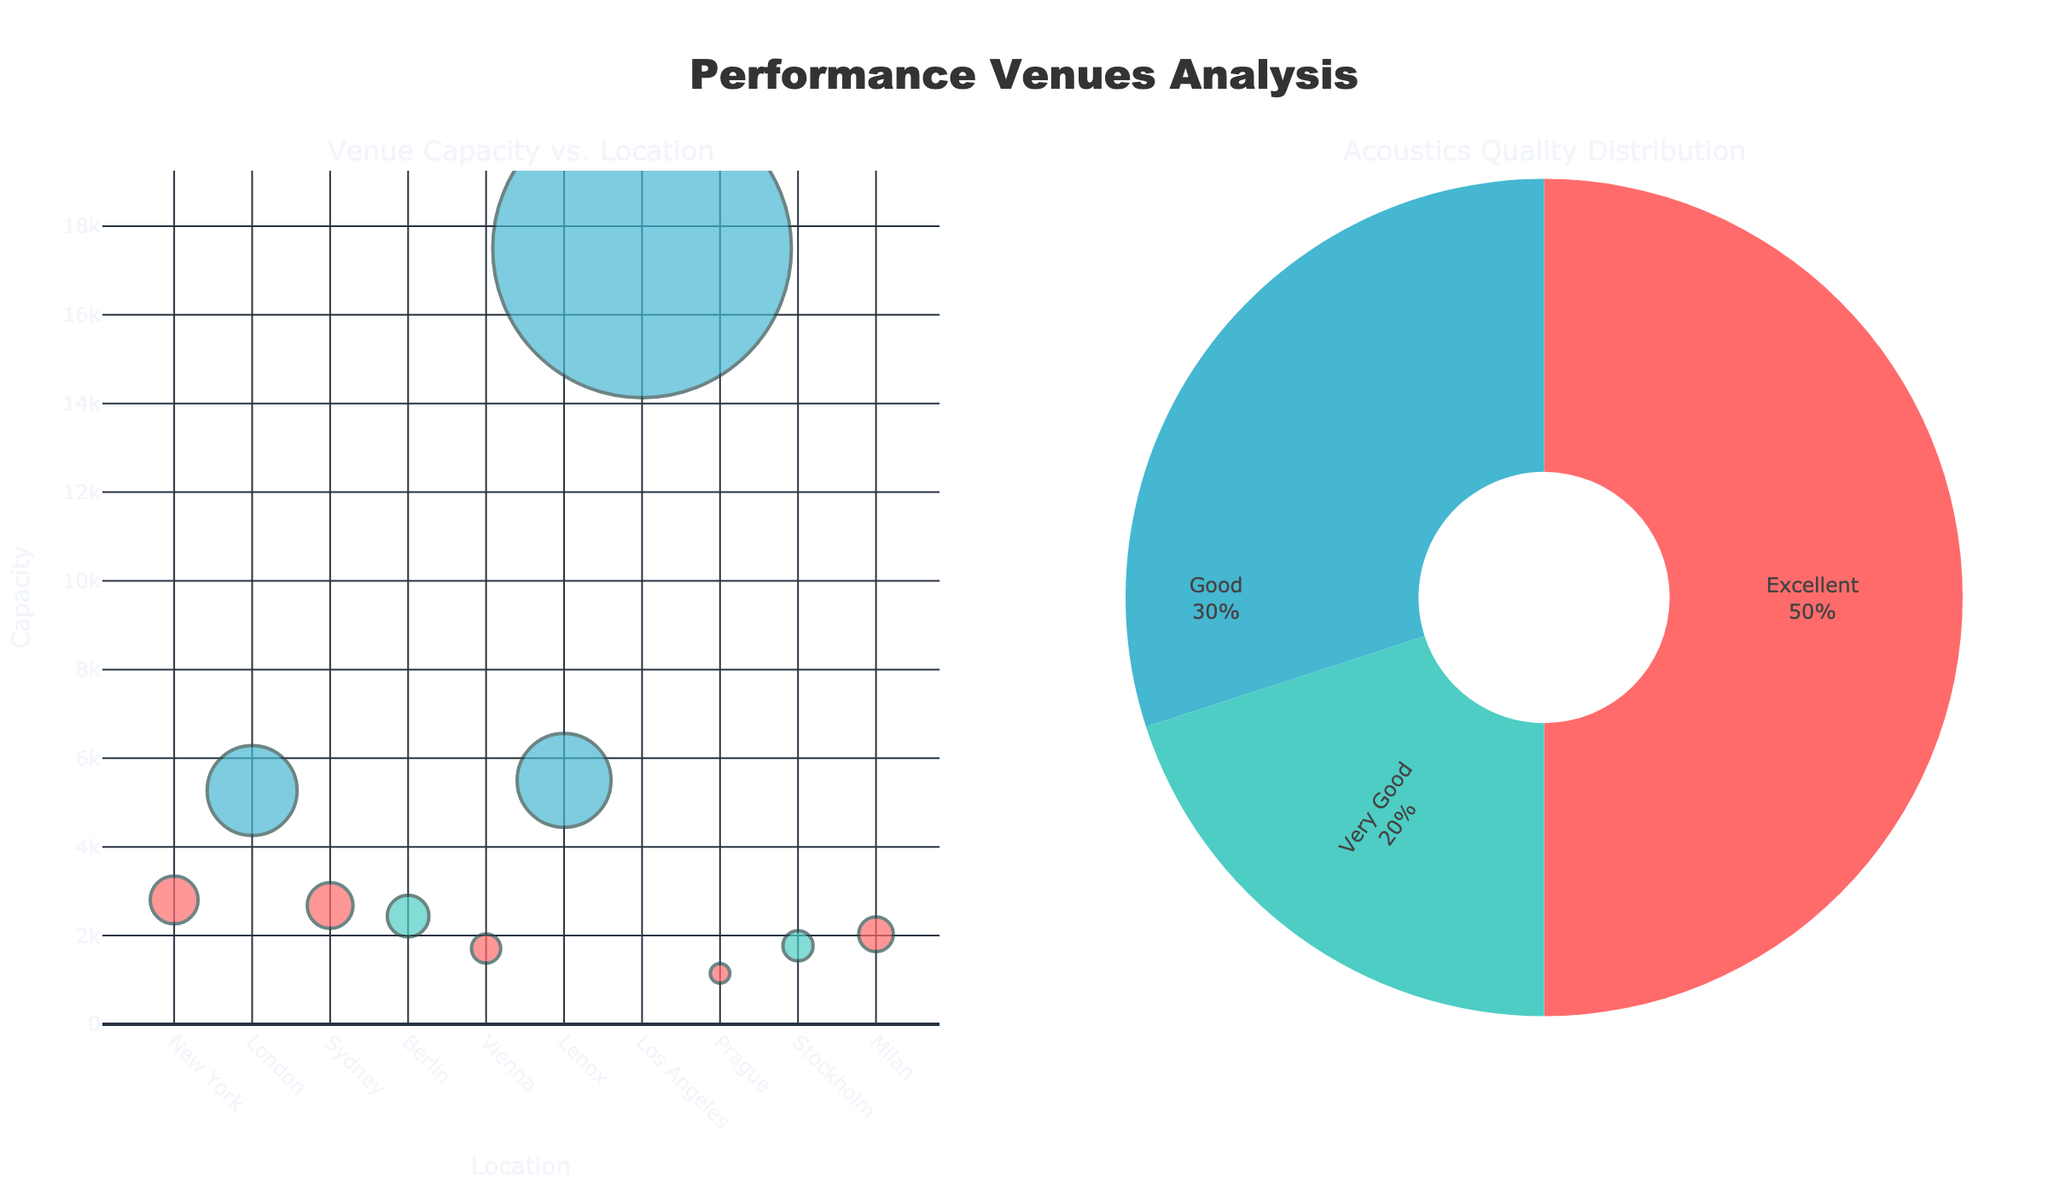What is the title of the figure? The title of the figure is positioned at the top center and provides an overview of the data representation. The title is "Performance Venues Analysis".
Answer: Performance Venues Analysis Which venue has the largest capacity? To find the venue with the largest capacity, look at the y-axis values in the scatter plot and identify the highest value. The Hollywood Bowl in Los Angeles has the largest capacity at 17,500.
Answer: Hollywood Bowl How many venues have an "Excellent" acoustics quality? This information can be found in the pie chart, which displays the distribution of acoustics quality. According to the pie chart, there are 5 venues with "Excellent" acoustics quality.
Answer: 5 What is the smallest venue by capacity, and what is its acoustics quality? Identify the smallest y-axis value in the scatter plot and cross-reference its color to determine the acoustics quality. The Rudolfinum in Prague has the smallest capacity of 1,148 and it has "Excellent" acoustics quality.
Answer: Rudolfinum, Excellent What are the capacities of the venues located in Europe? Identify the venues in European cities  (London, Berlin, Vienna, Prague, Stockholm, Milan) and check their y-axis values in the scatter plot. The capacities are: Royal Albert Hall (5272), Berlin Philharmonie (2440), Vienna State Opera (1709), Rudolfinum (1148), Konserthuset (1770), Teatro alla Scala (2030).
Answer: 5272, 2440, 1709, 1148, 1770, 2030 Which location has the second-largest venue, and what is its capacity? Find the second-highest value on the y-axis of the scatter plot. The second-largest venue is Tanglewood Music Center in Lenox, with a capacity of 5,500.
Answer: Lenox, 5500 Compare the capacities of venues with "Good" acoustics quality to those with "Very Good" acoustics quality. Add the capacities of the venues with "Good" acoustics (Royal Albert Hall, Tanglewood Music Center, Hollywood Bowl) and those with "Very Good" acoustics (Berlin Philharmonie, Konserthuset). "Good" equals 5272 + 5500 + 17500 = 28272; "Very Good" equals 2440 + 1770 = 4210.
Answer: Good: 28272, Very Good: 4210 What percentage of the venues have an "Excellent" acoustics quality? This information can be found in the pie chart, which contains percentage breakdowns. According to the pie chart, the percentage of venues with "Excellent" acoustics quality is approximately 50%.
Answer: 50% 